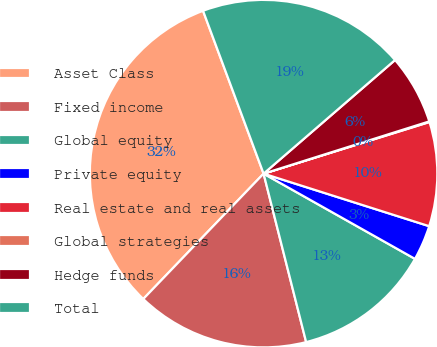<chart> <loc_0><loc_0><loc_500><loc_500><pie_chart><fcel>Asset Class<fcel>Fixed income<fcel>Global equity<fcel>Private equity<fcel>Real estate and real assets<fcel>Global strategies<fcel>Hedge funds<fcel>Total<nl><fcel>32.16%<fcel>16.11%<fcel>12.9%<fcel>3.27%<fcel>9.69%<fcel>0.06%<fcel>6.48%<fcel>19.32%<nl></chart> 